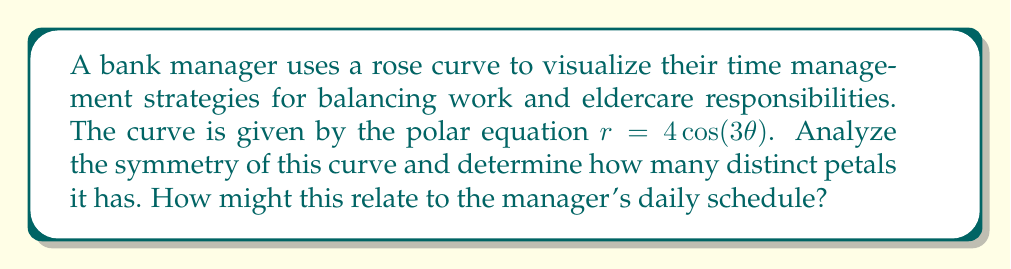Show me your answer to this math problem. To analyze the symmetry and determine the number of petals in the rose curve $r = 4\cos(3\theta)$, we follow these steps:

1) First, let's consider the general form of a rose curve: $r = a\cos(n\theta)$ or $r = a\sin(n\theta)$
   - If $n$ is odd, the curve has $n$ petals
   - If $n$ is even, the curve has $2n$ petals

2) In our case, $r = 4\cos(3\theta)$, so $a = 4$ and $n = 3$

3) Since $n = 3$, which is odd, the curve will have 3 petals

4) For symmetry analysis:
   - The curve is symmetric about the polar axis ($\theta = 0$) because $\cos(-\theta) = \cos(\theta)$
   - It's also symmetric about the line $\theta = \frac{\pi}{3}$ because $\cos(3(\frac{\pi}{3} - \theta)) = \cos(\pi - 3\theta) = -\cos(3\theta)$, which gives the same curve

5) The curve completes one full cycle when $3\theta = 2\pi$, or $\theta = \frac{2\pi}{3}$

[asy]
import graph;
size(200);
real r(real t) {return 4*cos(3*t);}
draw(polargraph(r,0,2*pi),red);
draw(circle(0,4),gray+dashed);
draw((0,0)--(4,0),blue,Arrow);
draw((0,0)--(2,3.464),blue,Arrow);
label("$\theta=0$",(4,0),E);
label("$\theta=\frac{\pi}{3}$",(2,3.464),NE);
[/asy]

Relating to the bank manager's schedule:
- The 3 petals could represent three main areas of focus: work responsibilities, eldercare duties, and personal time
- The symmetry suggests a balanced approach to these responsibilities
- The repetitive nature of the curve (completing a cycle every $\frac{2\pi}{3}$) might represent the cyclical nature of daily or weekly routines
Answer: The rose curve $r = 4\cos(3\theta)$ has 3 distinct petals. It is symmetric about the polar axis ($\theta = 0$) and the line $\theta = \frac{\pi}{3}$. 